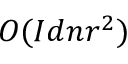<formula> <loc_0><loc_0><loc_500><loc_500>O ( I d n r ^ { 2 } )</formula> 